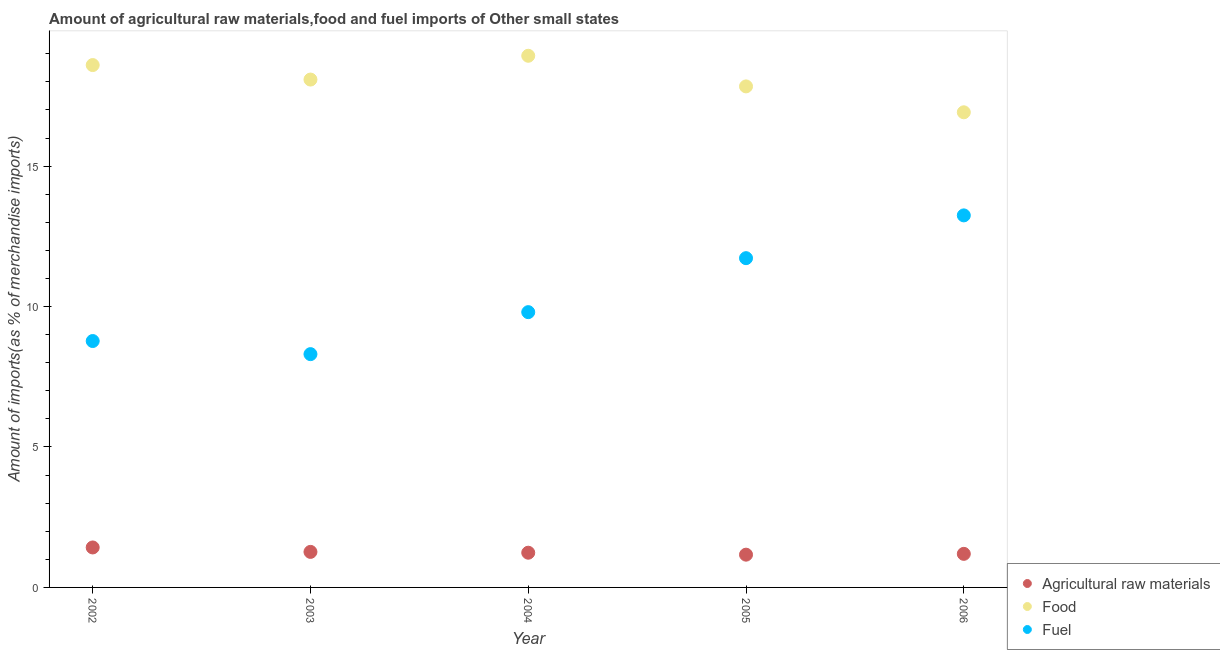How many different coloured dotlines are there?
Provide a short and direct response. 3. What is the percentage of raw materials imports in 2002?
Your response must be concise. 1.42. Across all years, what is the maximum percentage of fuel imports?
Your response must be concise. 13.25. Across all years, what is the minimum percentage of food imports?
Offer a very short reply. 16.92. In which year was the percentage of raw materials imports maximum?
Your response must be concise. 2002. In which year was the percentage of raw materials imports minimum?
Provide a succinct answer. 2005. What is the total percentage of food imports in the graph?
Provide a succinct answer. 90.36. What is the difference between the percentage of food imports in 2003 and that in 2004?
Your answer should be very brief. -0.85. What is the difference between the percentage of fuel imports in 2003 and the percentage of food imports in 2004?
Ensure brevity in your answer.  -10.62. What is the average percentage of fuel imports per year?
Your answer should be compact. 10.37. In the year 2005, what is the difference between the percentage of food imports and percentage of raw materials imports?
Offer a very short reply. 16.67. In how many years, is the percentage of raw materials imports greater than 14 %?
Give a very brief answer. 0. What is the ratio of the percentage of food imports in 2002 to that in 2004?
Offer a terse response. 0.98. Is the percentage of food imports in 2002 less than that in 2006?
Offer a very short reply. No. Is the difference between the percentage of fuel imports in 2003 and 2006 greater than the difference between the percentage of food imports in 2003 and 2006?
Provide a short and direct response. No. What is the difference between the highest and the second highest percentage of raw materials imports?
Offer a terse response. 0.16. What is the difference between the highest and the lowest percentage of fuel imports?
Give a very brief answer. 4.94. In how many years, is the percentage of raw materials imports greater than the average percentage of raw materials imports taken over all years?
Offer a very short reply. 2. Is it the case that in every year, the sum of the percentage of raw materials imports and percentage of food imports is greater than the percentage of fuel imports?
Provide a short and direct response. Yes. Is the percentage of food imports strictly greater than the percentage of raw materials imports over the years?
Offer a terse response. Yes. Is the percentage of raw materials imports strictly less than the percentage of food imports over the years?
Your response must be concise. Yes. How many years are there in the graph?
Your answer should be compact. 5. What is the difference between two consecutive major ticks on the Y-axis?
Make the answer very short. 5. Does the graph contain any zero values?
Offer a very short reply. No. Does the graph contain grids?
Ensure brevity in your answer.  No. Where does the legend appear in the graph?
Offer a terse response. Bottom right. How many legend labels are there?
Make the answer very short. 3. What is the title of the graph?
Ensure brevity in your answer.  Amount of agricultural raw materials,food and fuel imports of Other small states. What is the label or title of the X-axis?
Offer a very short reply. Year. What is the label or title of the Y-axis?
Make the answer very short. Amount of imports(as % of merchandise imports). What is the Amount of imports(as % of merchandise imports) in Agricultural raw materials in 2002?
Your response must be concise. 1.42. What is the Amount of imports(as % of merchandise imports) in Food in 2002?
Your answer should be compact. 18.6. What is the Amount of imports(as % of merchandise imports) in Fuel in 2002?
Your answer should be very brief. 8.77. What is the Amount of imports(as % of merchandise imports) in Agricultural raw materials in 2003?
Offer a very short reply. 1.27. What is the Amount of imports(as % of merchandise imports) in Food in 2003?
Your answer should be compact. 18.08. What is the Amount of imports(as % of merchandise imports) of Fuel in 2003?
Your answer should be very brief. 8.31. What is the Amount of imports(as % of merchandise imports) of Agricultural raw materials in 2004?
Make the answer very short. 1.24. What is the Amount of imports(as % of merchandise imports) of Food in 2004?
Your answer should be very brief. 18.93. What is the Amount of imports(as % of merchandise imports) in Fuel in 2004?
Your answer should be very brief. 9.8. What is the Amount of imports(as % of merchandise imports) of Agricultural raw materials in 2005?
Offer a terse response. 1.17. What is the Amount of imports(as % of merchandise imports) in Food in 2005?
Your response must be concise. 17.84. What is the Amount of imports(as % of merchandise imports) of Fuel in 2005?
Offer a terse response. 11.72. What is the Amount of imports(as % of merchandise imports) in Agricultural raw materials in 2006?
Offer a very short reply. 1.2. What is the Amount of imports(as % of merchandise imports) in Food in 2006?
Give a very brief answer. 16.92. What is the Amount of imports(as % of merchandise imports) in Fuel in 2006?
Give a very brief answer. 13.25. Across all years, what is the maximum Amount of imports(as % of merchandise imports) of Agricultural raw materials?
Provide a succinct answer. 1.42. Across all years, what is the maximum Amount of imports(as % of merchandise imports) in Food?
Give a very brief answer. 18.93. Across all years, what is the maximum Amount of imports(as % of merchandise imports) of Fuel?
Your response must be concise. 13.25. Across all years, what is the minimum Amount of imports(as % of merchandise imports) of Agricultural raw materials?
Your answer should be compact. 1.17. Across all years, what is the minimum Amount of imports(as % of merchandise imports) in Food?
Your response must be concise. 16.92. Across all years, what is the minimum Amount of imports(as % of merchandise imports) in Fuel?
Ensure brevity in your answer.  8.31. What is the total Amount of imports(as % of merchandise imports) of Agricultural raw materials in the graph?
Your answer should be very brief. 6.29. What is the total Amount of imports(as % of merchandise imports) in Food in the graph?
Give a very brief answer. 90.36. What is the total Amount of imports(as % of merchandise imports) in Fuel in the graph?
Your response must be concise. 51.85. What is the difference between the Amount of imports(as % of merchandise imports) of Agricultural raw materials in 2002 and that in 2003?
Make the answer very short. 0.16. What is the difference between the Amount of imports(as % of merchandise imports) in Food in 2002 and that in 2003?
Provide a succinct answer. 0.52. What is the difference between the Amount of imports(as % of merchandise imports) in Fuel in 2002 and that in 2003?
Provide a short and direct response. 0.47. What is the difference between the Amount of imports(as % of merchandise imports) in Agricultural raw materials in 2002 and that in 2004?
Ensure brevity in your answer.  0.19. What is the difference between the Amount of imports(as % of merchandise imports) of Food in 2002 and that in 2004?
Give a very brief answer. -0.33. What is the difference between the Amount of imports(as % of merchandise imports) of Fuel in 2002 and that in 2004?
Keep it short and to the point. -1.03. What is the difference between the Amount of imports(as % of merchandise imports) of Agricultural raw materials in 2002 and that in 2005?
Provide a succinct answer. 0.26. What is the difference between the Amount of imports(as % of merchandise imports) of Food in 2002 and that in 2005?
Make the answer very short. 0.76. What is the difference between the Amount of imports(as % of merchandise imports) of Fuel in 2002 and that in 2005?
Give a very brief answer. -2.95. What is the difference between the Amount of imports(as % of merchandise imports) in Agricultural raw materials in 2002 and that in 2006?
Offer a terse response. 0.23. What is the difference between the Amount of imports(as % of merchandise imports) of Food in 2002 and that in 2006?
Ensure brevity in your answer.  1.68. What is the difference between the Amount of imports(as % of merchandise imports) of Fuel in 2002 and that in 2006?
Your answer should be compact. -4.47. What is the difference between the Amount of imports(as % of merchandise imports) in Agricultural raw materials in 2003 and that in 2004?
Offer a terse response. 0.03. What is the difference between the Amount of imports(as % of merchandise imports) of Food in 2003 and that in 2004?
Your answer should be very brief. -0.85. What is the difference between the Amount of imports(as % of merchandise imports) in Fuel in 2003 and that in 2004?
Offer a terse response. -1.5. What is the difference between the Amount of imports(as % of merchandise imports) of Agricultural raw materials in 2003 and that in 2005?
Give a very brief answer. 0.1. What is the difference between the Amount of imports(as % of merchandise imports) in Food in 2003 and that in 2005?
Provide a succinct answer. 0.24. What is the difference between the Amount of imports(as % of merchandise imports) of Fuel in 2003 and that in 2005?
Your answer should be very brief. -3.42. What is the difference between the Amount of imports(as % of merchandise imports) in Agricultural raw materials in 2003 and that in 2006?
Ensure brevity in your answer.  0.07. What is the difference between the Amount of imports(as % of merchandise imports) in Food in 2003 and that in 2006?
Offer a very short reply. 1.17. What is the difference between the Amount of imports(as % of merchandise imports) in Fuel in 2003 and that in 2006?
Provide a short and direct response. -4.94. What is the difference between the Amount of imports(as % of merchandise imports) of Agricultural raw materials in 2004 and that in 2005?
Ensure brevity in your answer.  0.07. What is the difference between the Amount of imports(as % of merchandise imports) of Food in 2004 and that in 2005?
Ensure brevity in your answer.  1.09. What is the difference between the Amount of imports(as % of merchandise imports) of Fuel in 2004 and that in 2005?
Make the answer very short. -1.92. What is the difference between the Amount of imports(as % of merchandise imports) of Agricultural raw materials in 2004 and that in 2006?
Provide a short and direct response. 0.04. What is the difference between the Amount of imports(as % of merchandise imports) of Food in 2004 and that in 2006?
Ensure brevity in your answer.  2.01. What is the difference between the Amount of imports(as % of merchandise imports) in Fuel in 2004 and that in 2006?
Provide a succinct answer. -3.44. What is the difference between the Amount of imports(as % of merchandise imports) in Agricultural raw materials in 2005 and that in 2006?
Provide a succinct answer. -0.03. What is the difference between the Amount of imports(as % of merchandise imports) in Food in 2005 and that in 2006?
Ensure brevity in your answer.  0.92. What is the difference between the Amount of imports(as % of merchandise imports) in Fuel in 2005 and that in 2006?
Make the answer very short. -1.52. What is the difference between the Amount of imports(as % of merchandise imports) of Agricultural raw materials in 2002 and the Amount of imports(as % of merchandise imports) of Food in 2003?
Offer a very short reply. -16.66. What is the difference between the Amount of imports(as % of merchandise imports) in Agricultural raw materials in 2002 and the Amount of imports(as % of merchandise imports) in Fuel in 2003?
Give a very brief answer. -6.88. What is the difference between the Amount of imports(as % of merchandise imports) in Food in 2002 and the Amount of imports(as % of merchandise imports) in Fuel in 2003?
Provide a short and direct response. 10.29. What is the difference between the Amount of imports(as % of merchandise imports) in Agricultural raw materials in 2002 and the Amount of imports(as % of merchandise imports) in Food in 2004?
Your answer should be compact. -17.5. What is the difference between the Amount of imports(as % of merchandise imports) in Agricultural raw materials in 2002 and the Amount of imports(as % of merchandise imports) in Fuel in 2004?
Make the answer very short. -8.38. What is the difference between the Amount of imports(as % of merchandise imports) in Food in 2002 and the Amount of imports(as % of merchandise imports) in Fuel in 2004?
Offer a very short reply. 8.8. What is the difference between the Amount of imports(as % of merchandise imports) in Agricultural raw materials in 2002 and the Amount of imports(as % of merchandise imports) in Food in 2005?
Ensure brevity in your answer.  -16.41. What is the difference between the Amount of imports(as % of merchandise imports) of Agricultural raw materials in 2002 and the Amount of imports(as % of merchandise imports) of Fuel in 2005?
Ensure brevity in your answer.  -10.3. What is the difference between the Amount of imports(as % of merchandise imports) of Food in 2002 and the Amount of imports(as % of merchandise imports) of Fuel in 2005?
Make the answer very short. 6.87. What is the difference between the Amount of imports(as % of merchandise imports) of Agricultural raw materials in 2002 and the Amount of imports(as % of merchandise imports) of Food in 2006?
Your answer should be very brief. -15.49. What is the difference between the Amount of imports(as % of merchandise imports) of Agricultural raw materials in 2002 and the Amount of imports(as % of merchandise imports) of Fuel in 2006?
Ensure brevity in your answer.  -11.82. What is the difference between the Amount of imports(as % of merchandise imports) of Food in 2002 and the Amount of imports(as % of merchandise imports) of Fuel in 2006?
Your answer should be very brief. 5.35. What is the difference between the Amount of imports(as % of merchandise imports) of Agricultural raw materials in 2003 and the Amount of imports(as % of merchandise imports) of Food in 2004?
Offer a very short reply. -17.66. What is the difference between the Amount of imports(as % of merchandise imports) in Agricultural raw materials in 2003 and the Amount of imports(as % of merchandise imports) in Fuel in 2004?
Your answer should be very brief. -8.54. What is the difference between the Amount of imports(as % of merchandise imports) of Food in 2003 and the Amount of imports(as % of merchandise imports) of Fuel in 2004?
Provide a succinct answer. 8.28. What is the difference between the Amount of imports(as % of merchandise imports) in Agricultural raw materials in 2003 and the Amount of imports(as % of merchandise imports) in Food in 2005?
Offer a very short reply. -16.57. What is the difference between the Amount of imports(as % of merchandise imports) in Agricultural raw materials in 2003 and the Amount of imports(as % of merchandise imports) in Fuel in 2005?
Keep it short and to the point. -10.46. What is the difference between the Amount of imports(as % of merchandise imports) in Food in 2003 and the Amount of imports(as % of merchandise imports) in Fuel in 2005?
Keep it short and to the point. 6.36. What is the difference between the Amount of imports(as % of merchandise imports) in Agricultural raw materials in 2003 and the Amount of imports(as % of merchandise imports) in Food in 2006?
Your answer should be compact. -15.65. What is the difference between the Amount of imports(as % of merchandise imports) of Agricultural raw materials in 2003 and the Amount of imports(as % of merchandise imports) of Fuel in 2006?
Ensure brevity in your answer.  -11.98. What is the difference between the Amount of imports(as % of merchandise imports) in Food in 2003 and the Amount of imports(as % of merchandise imports) in Fuel in 2006?
Provide a succinct answer. 4.84. What is the difference between the Amount of imports(as % of merchandise imports) in Agricultural raw materials in 2004 and the Amount of imports(as % of merchandise imports) in Food in 2005?
Offer a terse response. -16.6. What is the difference between the Amount of imports(as % of merchandise imports) in Agricultural raw materials in 2004 and the Amount of imports(as % of merchandise imports) in Fuel in 2005?
Your answer should be very brief. -10.49. What is the difference between the Amount of imports(as % of merchandise imports) in Food in 2004 and the Amount of imports(as % of merchandise imports) in Fuel in 2005?
Provide a short and direct response. 7.21. What is the difference between the Amount of imports(as % of merchandise imports) of Agricultural raw materials in 2004 and the Amount of imports(as % of merchandise imports) of Food in 2006?
Make the answer very short. -15.68. What is the difference between the Amount of imports(as % of merchandise imports) in Agricultural raw materials in 2004 and the Amount of imports(as % of merchandise imports) in Fuel in 2006?
Provide a short and direct response. -12.01. What is the difference between the Amount of imports(as % of merchandise imports) in Food in 2004 and the Amount of imports(as % of merchandise imports) in Fuel in 2006?
Your answer should be very brief. 5.68. What is the difference between the Amount of imports(as % of merchandise imports) of Agricultural raw materials in 2005 and the Amount of imports(as % of merchandise imports) of Food in 2006?
Give a very brief answer. -15.75. What is the difference between the Amount of imports(as % of merchandise imports) of Agricultural raw materials in 2005 and the Amount of imports(as % of merchandise imports) of Fuel in 2006?
Keep it short and to the point. -12.08. What is the difference between the Amount of imports(as % of merchandise imports) in Food in 2005 and the Amount of imports(as % of merchandise imports) in Fuel in 2006?
Offer a very short reply. 4.59. What is the average Amount of imports(as % of merchandise imports) of Agricultural raw materials per year?
Offer a very short reply. 1.26. What is the average Amount of imports(as % of merchandise imports) in Food per year?
Give a very brief answer. 18.07. What is the average Amount of imports(as % of merchandise imports) of Fuel per year?
Your answer should be very brief. 10.37. In the year 2002, what is the difference between the Amount of imports(as % of merchandise imports) in Agricultural raw materials and Amount of imports(as % of merchandise imports) in Food?
Provide a short and direct response. -17.17. In the year 2002, what is the difference between the Amount of imports(as % of merchandise imports) of Agricultural raw materials and Amount of imports(as % of merchandise imports) of Fuel?
Offer a terse response. -7.35. In the year 2002, what is the difference between the Amount of imports(as % of merchandise imports) in Food and Amount of imports(as % of merchandise imports) in Fuel?
Offer a very short reply. 9.82. In the year 2003, what is the difference between the Amount of imports(as % of merchandise imports) of Agricultural raw materials and Amount of imports(as % of merchandise imports) of Food?
Make the answer very short. -16.82. In the year 2003, what is the difference between the Amount of imports(as % of merchandise imports) of Agricultural raw materials and Amount of imports(as % of merchandise imports) of Fuel?
Give a very brief answer. -7.04. In the year 2003, what is the difference between the Amount of imports(as % of merchandise imports) of Food and Amount of imports(as % of merchandise imports) of Fuel?
Keep it short and to the point. 9.78. In the year 2004, what is the difference between the Amount of imports(as % of merchandise imports) of Agricultural raw materials and Amount of imports(as % of merchandise imports) of Food?
Your response must be concise. -17.69. In the year 2004, what is the difference between the Amount of imports(as % of merchandise imports) in Agricultural raw materials and Amount of imports(as % of merchandise imports) in Fuel?
Your response must be concise. -8.56. In the year 2004, what is the difference between the Amount of imports(as % of merchandise imports) of Food and Amount of imports(as % of merchandise imports) of Fuel?
Give a very brief answer. 9.13. In the year 2005, what is the difference between the Amount of imports(as % of merchandise imports) in Agricultural raw materials and Amount of imports(as % of merchandise imports) in Food?
Keep it short and to the point. -16.67. In the year 2005, what is the difference between the Amount of imports(as % of merchandise imports) of Agricultural raw materials and Amount of imports(as % of merchandise imports) of Fuel?
Provide a short and direct response. -10.56. In the year 2005, what is the difference between the Amount of imports(as % of merchandise imports) in Food and Amount of imports(as % of merchandise imports) in Fuel?
Provide a short and direct response. 6.12. In the year 2006, what is the difference between the Amount of imports(as % of merchandise imports) of Agricultural raw materials and Amount of imports(as % of merchandise imports) of Food?
Your answer should be very brief. -15.72. In the year 2006, what is the difference between the Amount of imports(as % of merchandise imports) of Agricultural raw materials and Amount of imports(as % of merchandise imports) of Fuel?
Your response must be concise. -12.05. In the year 2006, what is the difference between the Amount of imports(as % of merchandise imports) of Food and Amount of imports(as % of merchandise imports) of Fuel?
Provide a succinct answer. 3.67. What is the ratio of the Amount of imports(as % of merchandise imports) of Agricultural raw materials in 2002 to that in 2003?
Offer a very short reply. 1.12. What is the ratio of the Amount of imports(as % of merchandise imports) of Food in 2002 to that in 2003?
Your response must be concise. 1.03. What is the ratio of the Amount of imports(as % of merchandise imports) of Fuel in 2002 to that in 2003?
Keep it short and to the point. 1.06. What is the ratio of the Amount of imports(as % of merchandise imports) of Agricultural raw materials in 2002 to that in 2004?
Offer a terse response. 1.15. What is the ratio of the Amount of imports(as % of merchandise imports) in Food in 2002 to that in 2004?
Make the answer very short. 0.98. What is the ratio of the Amount of imports(as % of merchandise imports) of Fuel in 2002 to that in 2004?
Your response must be concise. 0.9. What is the ratio of the Amount of imports(as % of merchandise imports) in Agricultural raw materials in 2002 to that in 2005?
Your answer should be compact. 1.22. What is the ratio of the Amount of imports(as % of merchandise imports) in Food in 2002 to that in 2005?
Offer a terse response. 1.04. What is the ratio of the Amount of imports(as % of merchandise imports) in Fuel in 2002 to that in 2005?
Ensure brevity in your answer.  0.75. What is the ratio of the Amount of imports(as % of merchandise imports) of Agricultural raw materials in 2002 to that in 2006?
Your answer should be very brief. 1.19. What is the ratio of the Amount of imports(as % of merchandise imports) of Food in 2002 to that in 2006?
Your answer should be compact. 1.1. What is the ratio of the Amount of imports(as % of merchandise imports) of Fuel in 2002 to that in 2006?
Make the answer very short. 0.66. What is the ratio of the Amount of imports(as % of merchandise imports) of Agricultural raw materials in 2003 to that in 2004?
Your answer should be very brief. 1.02. What is the ratio of the Amount of imports(as % of merchandise imports) in Food in 2003 to that in 2004?
Provide a short and direct response. 0.96. What is the ratio of the Amount of imports(as % of merchandise imports) in Fuel in 2003 to that in 2004?
Provide a short and direct response. 0.85. What is the ratio of the Amount of imports(as % of merchandise imports) in Agricultural raw materials in 2003 to that in 2005?
Ensure brevity in your answer.  1.08. What is the ratio of the Amount of imports(as % of merchandise imports) in Food in 2003 to that in 2005?
Provide a short and direct response. 1.01. What is the ratio of the Amount of imports(as % of merchandise imports) of Fuel in 2003 to that in 2005?
Ensure brevity in your answer.  0.71. What is the ratio of the Amount of imports(as % of merchandise imports) in Agricultural raw materials in 2003 to that in 2006?
Your answer should be very brief. 1.06. What is the ratio of the Amount of imports(as % of merchandise imports) of Food in 2003 to that in 2006?
Offer a terse response. 1.07. What is the ratio of the Amount of imports(as % of merchandise imports) in Fuel in 2003 to that in 2006?
Provide a succinct answer. 0.63. What is the ratio of the Amount of imports(as % of merchandise imports) of Agricultural raw materials in 2004 to that in 2005?
Provide a short and direct response. 1.06. What is the ratio of the Amount of imports(as % of merchandise imports) of Food in 2004 to that in 2005?
Provide a succinct answer. 1.06. What is the ratio of the Amount of imports(as % of merchandise imports) of Fuel in 2004 to that in 2005?
Your response must be concise. 0.84. What is the ratio of the Amount of imports(as % of merchandise imports) in Agricultural raw materials in 2004 to that in 2006?
Your response must be concise. 1.03. What is the ratio of the Amount of imports(as % of merchandise imports) in Food in 2004 to that in 2006?
Make the answer very short. 1.12. What is the ratio of the Amount of imports(as % of merchandise imports) of Fuel in 2004 to that in 2006?
Make the answer very short. 0.74. What is the ratio of the Amount of imports(as % of merchandise imports) of Agricultural raw materials in 2005 to that in 2006?
Your response must be concise. 0.98. What is the ratio of the Amount of imports(as % of merchandise imports) of Food in 2005 to that in 2006?
Offer a terse response. 1.05. What is the ratio of the Amount of imports(as % of merchandise imports) of Fuel in 2005 to that in 2006?
Your response must be concise. 0.89. What is the difference between the highest and the second highest Amount of imports(as % of merchandise imports) of Agricultural raw materials?
Offer a very short reply. 0.16. What is the difference between the highest and the second highest Amount of imports(as % of merchandise imports) of Food?
Provide a succinct answer. 0.33. What is the difference between the highest and the second highest Amount of imports(as % of merchandise imports) of Fuel?
Ensure brevity in your answer.  1.52. What is the difference between the highest and the lowest Amount of imports(as % of merchandise imports) in Agricultural raw materials?
Keep it short and to the point. 0.26. What is the difference between the highest and the lowest Amount of imports(as % of merchandise imports) in Food?
Your response must be concise. 2.01. What is the difference between the highest and the lowest Amount of imports(as % of merchandise imports) of Fuel?
Provide a short and direct response. 4.94. 